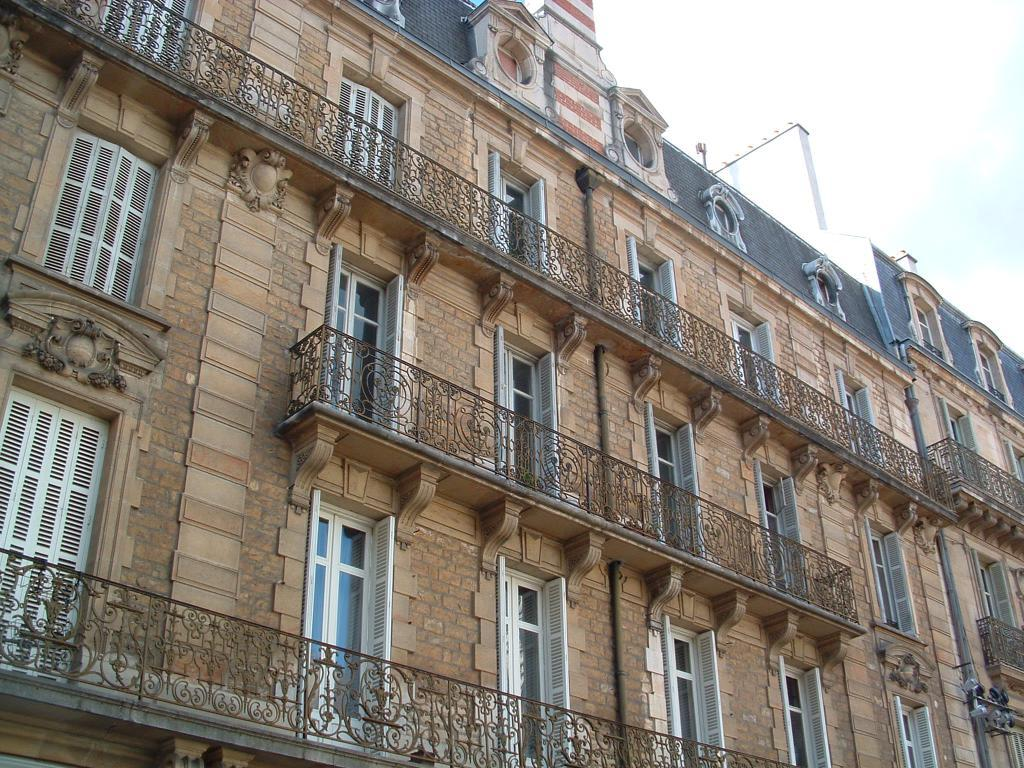What structures are located in the foreground of the image? There are buildings in the foreground of the image. What architectural feature can be seen on the buildings? Windows are visible in the image. What is located in front of the buildings in the foreground? There is a fence in the foreground of the image. What part of the natural environment is visible in the image? The sky is visible in the top right corner of the image. What time of day might the image have been taken? The image was likely taken during the day, as the sky is visible and not dark. What type of competition is being held in the image? There is no competition present in the image; it features buildings, a fence, and the sky. What type of stem can be seen growing from the buildings in the image? There are no plants or stems visible in the image; it features buildings, a fence, and the sky. 